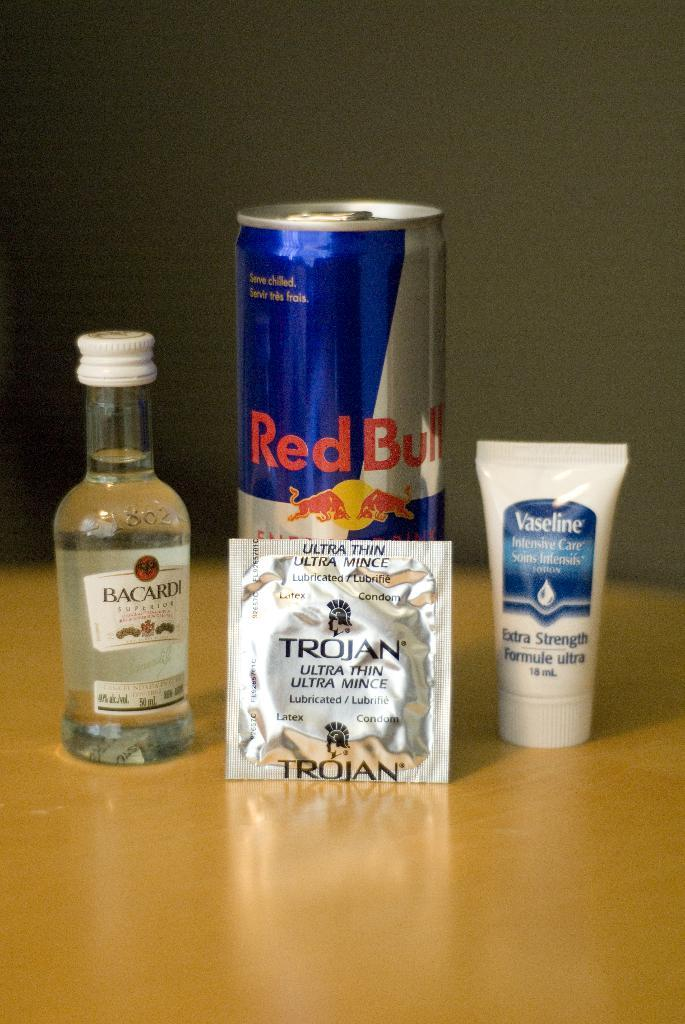<image>
Provide a brief description of the given image. A photo, tongue in cheek perhaps with a "bundle" of Red Bull, Bacardi, a Trojan and of course, vaseline 